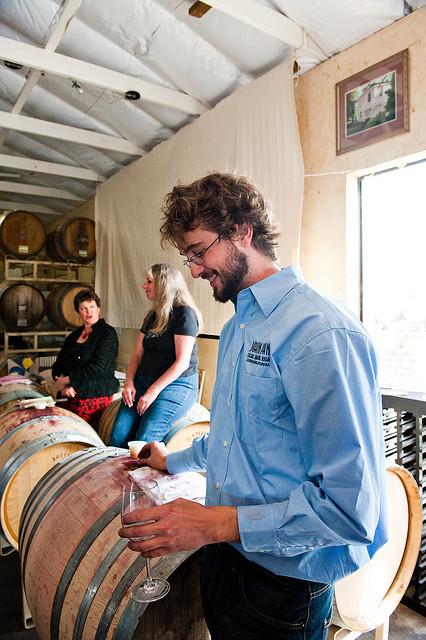What is in those barrels?
Keep it brief. Wine. Is there a ceiling in this picture?
Write a very short answer. Yes. Are these people working?
Write a very short answer. No. 